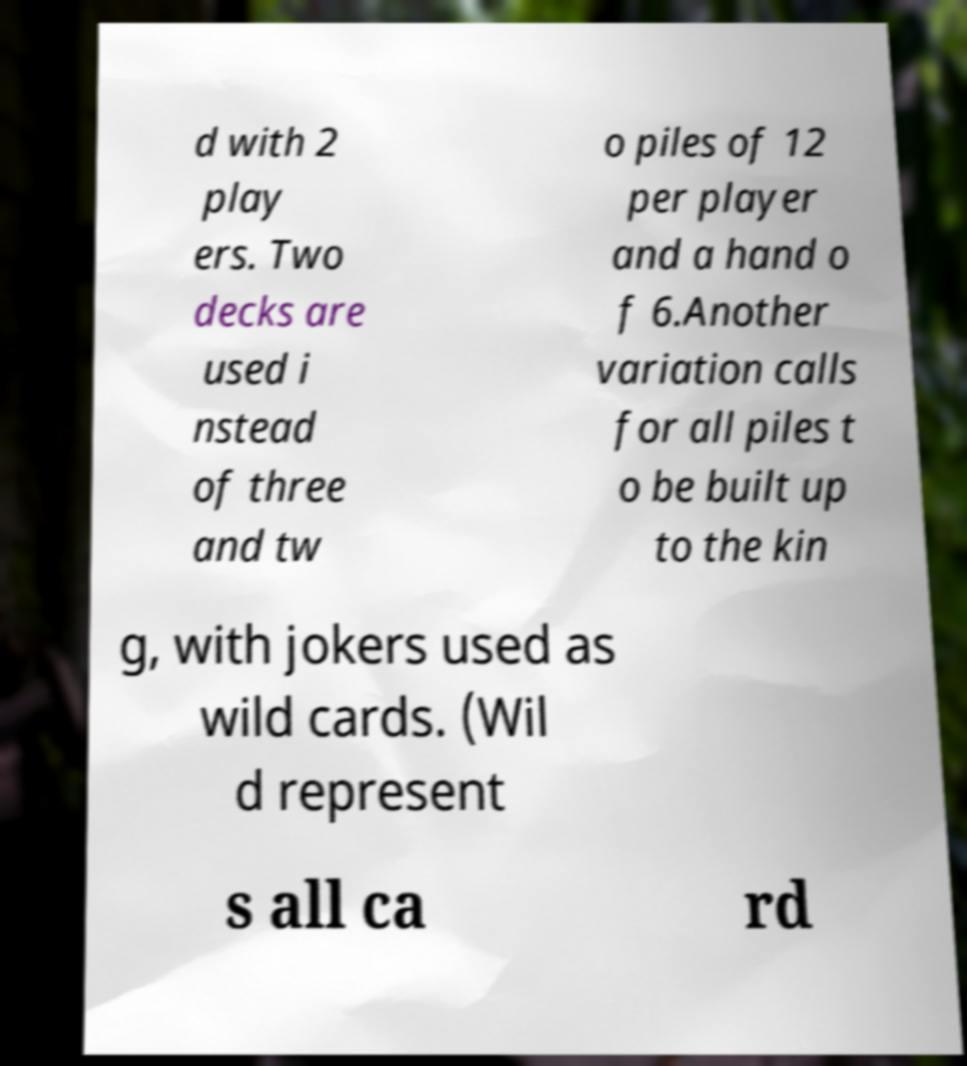There's text embedded in this image that I need extracted. Can you transcribe it verbatim? d with 2 play ers. Two decks are used i nstead of three and tw o piles of 12 per player and a hand o f 6.Another variation calls for all piles t o be built up to the kin g, with jokers used as wild cards. (Wil d represent s all ca rd 